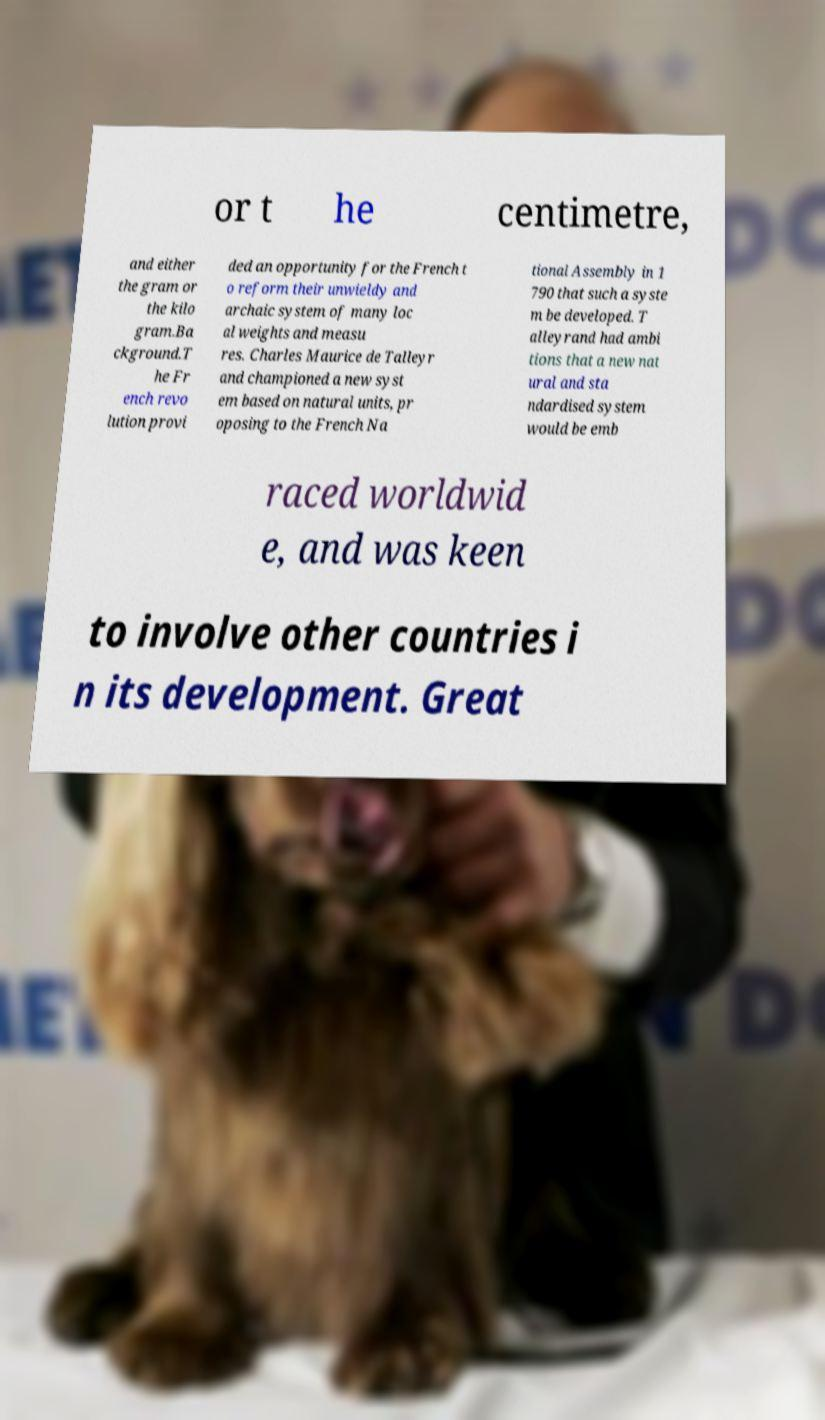What messages or text are displayed in this image? I need them in a readable, typed format. or t he centimetre, and either the gram or the kilo gram.Ba ckground.T he Fr ench revo lution provi ded an opportunity for the French t o reform their unwieldy and archaic system of many loc al weights and measu res. Charles Maurice de Talleyr and championed a new syst em based on natural units, pr oposing to the French Na tional Assembly in 1 790 that such a syste m be developed. T alleyrand had ambi tions that a new nat ural and sta ndardised system would be emb raced worldwid e, and was keen to involve other countries i n its development. Great 